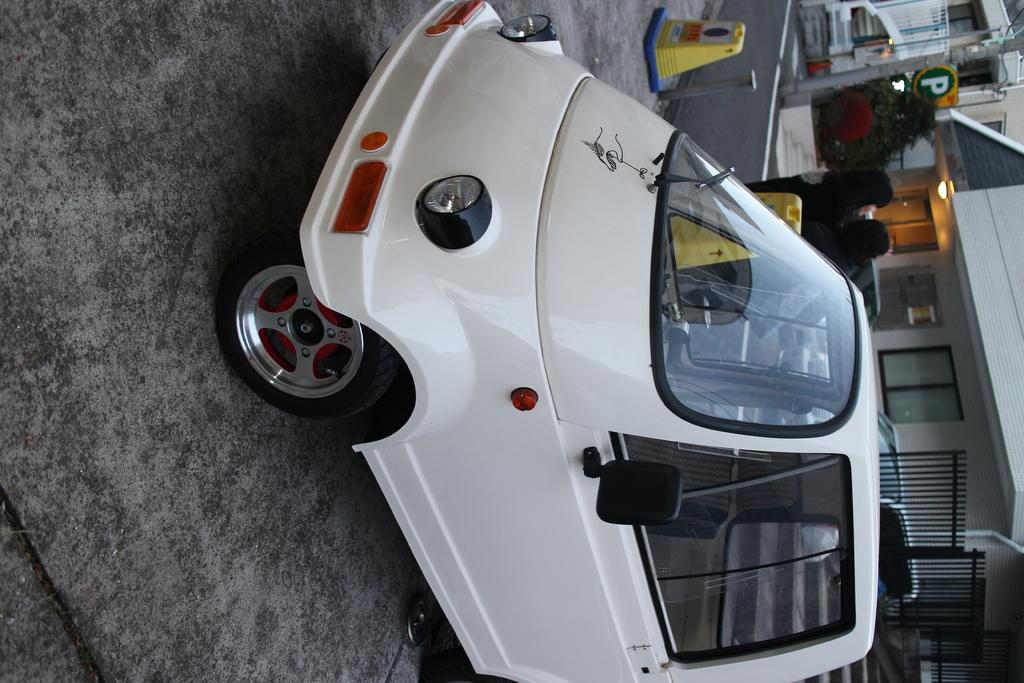What type of vehicle is parked on the road in the image? There is a white vehicle parked on the road in the image. What can be seen in the background of the image? In the background, there are poles, stairs, grills, houses, walls, windows, plants, lights, a board, a road, and other objects. What shape is the branch that is being burned in the image? There is no branch being burned in the image; the provided facts do not mention any burning objects. 